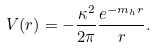<formula> <loc_0><loc_0><loc_500><loc_500>V ( r ) = - \frac { \kappa ^ { 2 } } { 2 \pi } \frac { e ^ { - m _ { h } r } } { r } .</formula> 